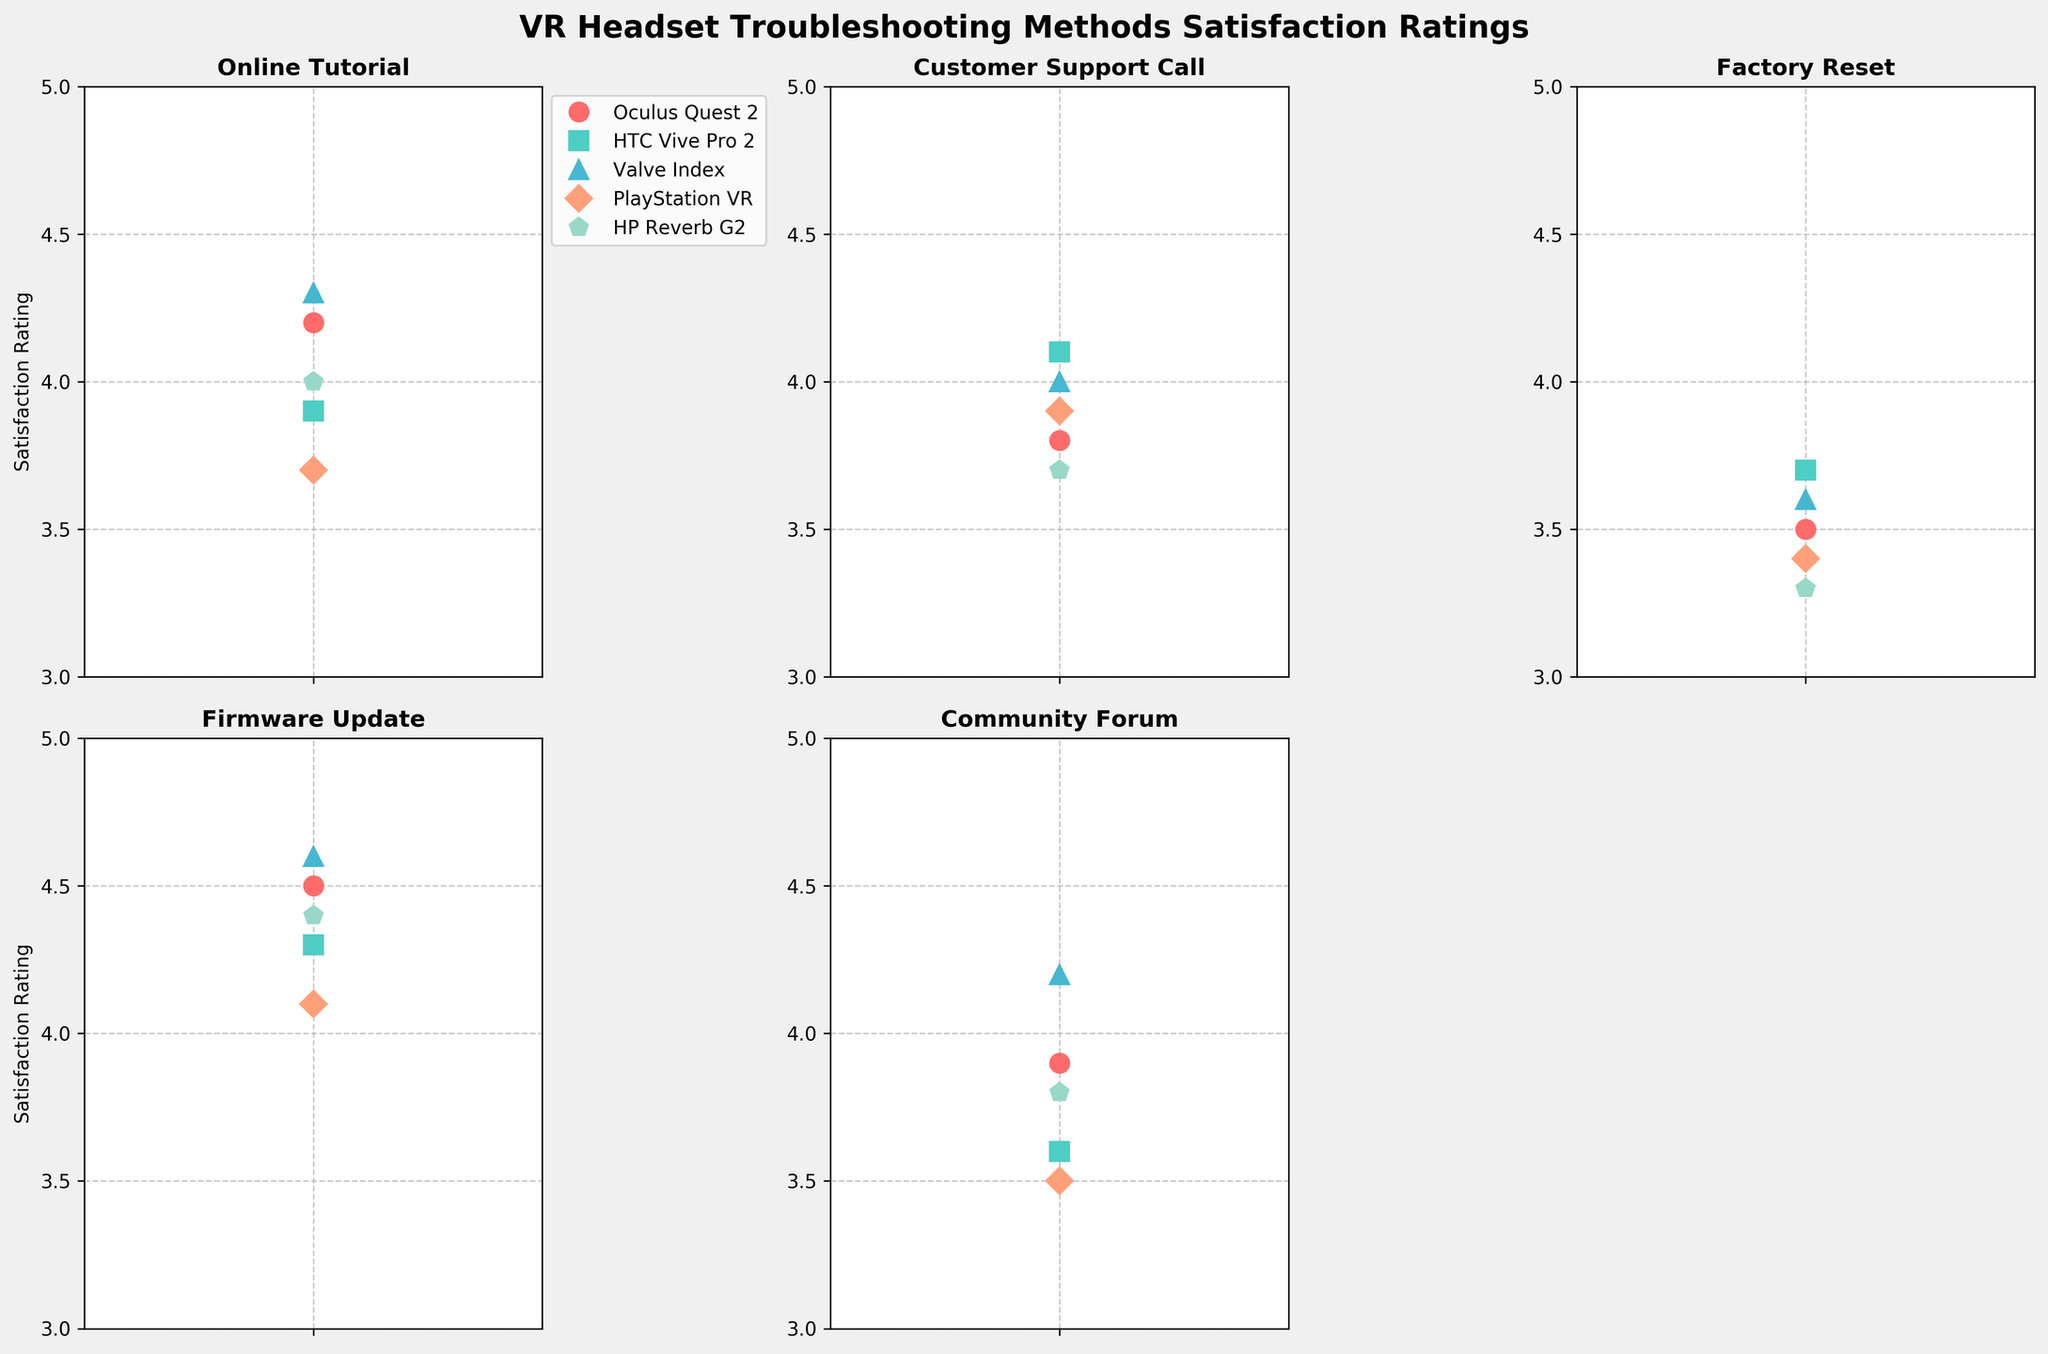What is the title of the figure? The title is usually found above the main plot or grid of subplots. It summarizes the main topic or purpose of the figure. Here, the title is clearly written at the top of the figure: 'VR Headset Troubleshooting Methods Satisfaction Ratings'.
Answer: VR Headset Troubleshooting Methods Satisfaction Ratings What is the highest user satisfaction rating for the Valve Index? To answer this, look at the line corresponding to the Valve Index in each subplot. The highest rating can be identified visually. Here, the highest rating for Valve Index is for 'Firmware Update' in the fourth subplot.
Answer: 4.6 Which headset received the lowest satisfaction rating for the 'Factory Reset' method? Examine the 'Factory Reset' subplot and compare the ratings for each headset. The lowest rating here is for HP Reverb G2.
Answer: HP Reverb G2 What is the average satisfaction rating for the PlayStation VR across all methods? To find the average, sum all the ratings for PlayStation VR and divide by the number of methods. The ratings are 3.7, 3.9, 3.4, 4.1, and 3.5. The sum is 3.7 + 3.9 + 3.4 + 4.1 + 3.5 = 18.6. Divide by 5 (number of methods), the average rating is 18.6 / 5.
Answer: 3.72 Which headset has the most consistent satisfaction ratings across all methods? To determine consistency, look for the headset with ratings that vary the least. This can be gauged by minimal difference between the highest and lowest ratings. The Oculus Quest 2 has the ratings 4.2, 3.8, 3.5, 4.5, and 3.9, with a range of 4.5 - 3.5 = 1. The Valve Index has the ratings 4.3, 4.0, 3.6, 4.6, and 4.2, with a range of 4.6 - 3.6 = 1.0, similar to Oculus Quest 2, making them both consistent.
Answer: Oculus Quest 2 / Valve Index How does the 'Community Forum' satisfaction for HTC Vive Pro 2 compare to that for the HP Reverb G2? Look at the subplot for 'Community Forum' and compare the ratings for both headsets. HTC Vive Pro 2 has a rating of 3.6, while HP Reverb G2 has a rating of 3.8.
Answer: HP Reverb G2 has a higher rating Which troubleshooting method has different satisfaction ratings with the largest spread for different headsets? Identify the method with the largest difference between the highest and lowest ratings. The 'Factory Reset' method has ratings 3.5, 3.7, 3.6, 3.4, and 3.3. The spread is 3.7 - 3.3 = 0.4, which is significantly larger than other methods' spreads.
Answer: Factory Reset Which headset and method combination yields the lowest overall satisfaction rating? Find the lowest single rating across all headsets and methods. By examining all subplots, the lowest rating is 3.3 for HP Reverb G2 using the 'Factory Reset' method.
Answer: HP Reverb G2 and Factory Reset What is the difference in satisfaction ratings between 'Firmware Update' and 'Customer Support Call' for the HTC Vive Pro 2? Locate the ratings for HTC Vive Pro 2 under 'Firmware Update' (4.3) and 'Customer Support Call' (4.1). Subtract the lesser from the greater rating: 4.3 - 4.1.
Answer: 0.2 Which VR headset has the highest average rating across all methods? Calculate the average rating for each headset across all methods. Valve Index: (4.3+4.0+3.6+4.6+4.2)/5 = 4.14, Oculus Quest 2: (4.2+3.8+3.5+4.5+3.9)/5 = 3.98, and so on. The highest average is for Valve Index.
Answer: Valve Index 